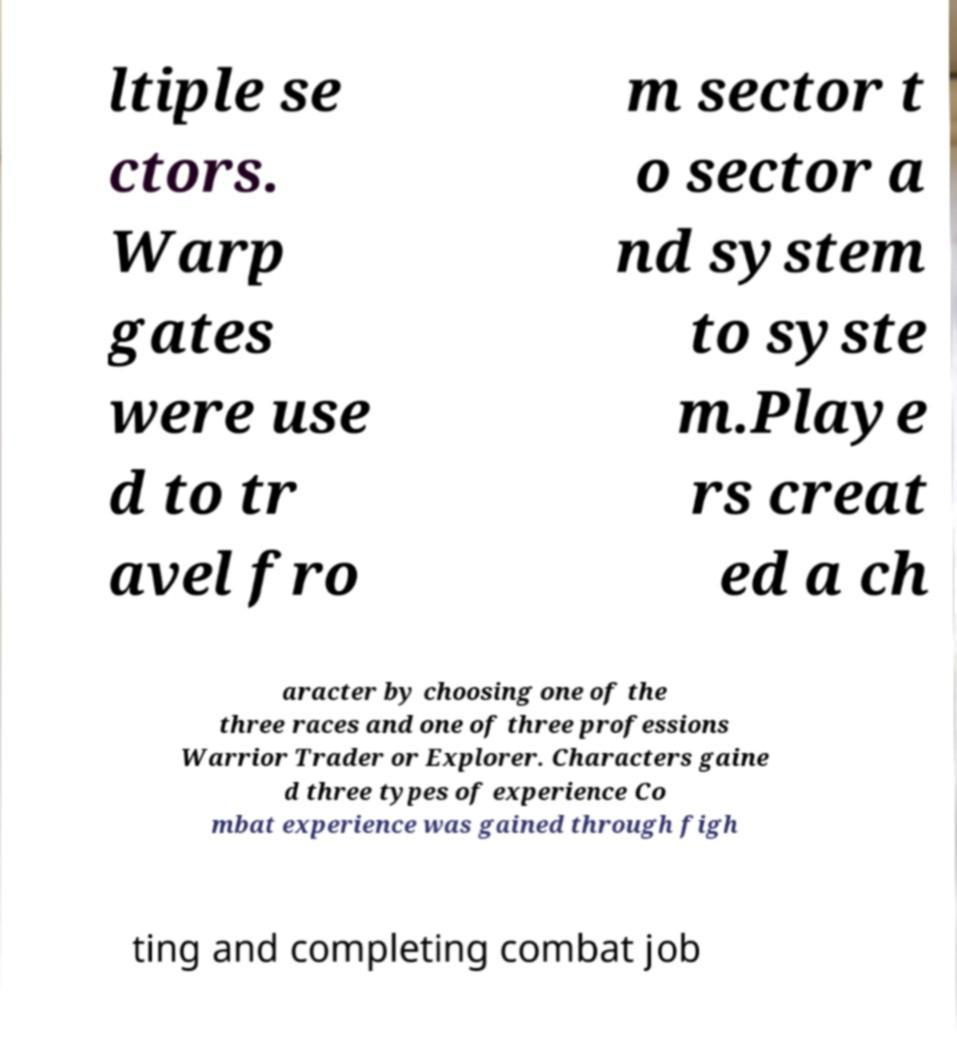There's text embedded in this image that I need extracted. Can you transcribe it verbatim? ltiple se ctors. Warp gates were use d to tr avel fro m sector t o sector a nd system to syste m.Playe rs creat ed a ch aracter by choosing one of the three races and one of three professions Warrior Trader or Explorer. Characters gaine d three types of experience Co mbat experience was gained through figh ting and completing combat job 